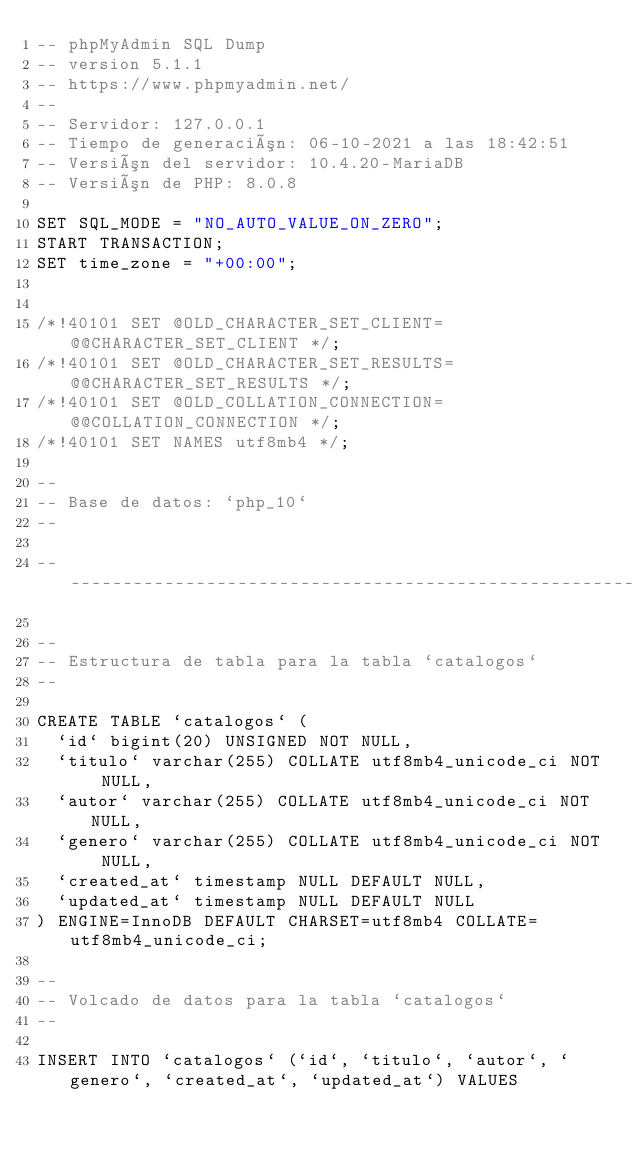Convert code to text. <code><loc_0><loc_0><loc_500><loc_500><_SQL_>-- phpMyAdmin SQL Dump
-- version 5.1.1
-- https://www.phpmyadmin.net/
--
-- Servidor: 127.0.0.1
-- Tiempo de generación: 06-10-2021 a las 18:42:51
-- Versión del servidor: 10.4.20-MariaDB
-- Versión de PHP: 8.0.8

SET SQL_MODE = "NO_AUTO_VALUE_ON_ZERO";
START TRANSACTION;
SET time_zone = "+00:00";


/*!40101 SET @OLD_CHARACTER_SET_CLIENT=@@CHARACTER_SET_CLIENT */;
/*!40101 SET @OLD_CHARACTER_SET_RESULTS=@@CHARACTER_SET_RESULTS */;
/*!40101 SET @OLD_COLLATION_CONNECTION=@@COLLATION_CONNECTION */;
/*!40101 SET NAMES utf8mb4 */;

--
-- Base de datos: `php_10`
--

-- --------------------------------------------------------

--
-- Estructura de tabla para la tabla `catalogos`
--

CREATE TABLE `catalogos` (
  `id` bigint(20) UNSIGNED NOT NULL,
  `titulo` varchar(255) COLLATE utf8mb4_unicode_ci NOT NULL,
  `autor` varchar(255) COLLATE utf8mb4_unicode_ci NOT NULL,
  `genero` varchar(255) COLLATE utf8mb4_unicode_ci NOT NULL,
  `created_at` timestamp NULL DEFAULT NULL,
  `updated_at` timestamp NULL DEFAULT NULL
) ENGINE=InnoDB DEFAULT CHARSET=utf8mb4 COLLATE=utf8mb4_unicode_ci;

--
-- Volcado de datos para la tabla `catalogos`
--

INSERT INTO `catalogos` (`id`, `titulo`, `autor`, `genero`, `created_at`, `updated_at`) VALUES</code> 